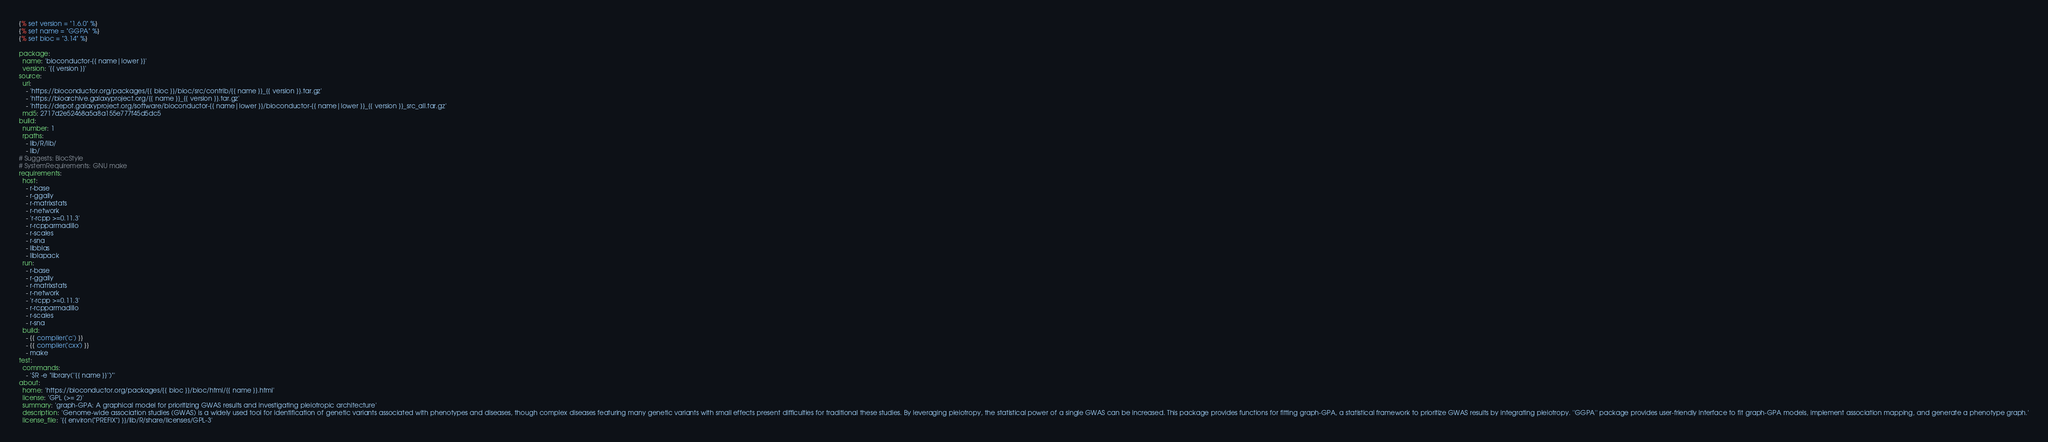<code> <loc_0><loc_0><loc_500><loc_500><_YAML_>{% set version = "1.6.0" %}
{% set name = "GGPA" %}
{% set bioc = "3.14" %}

package:
  name: 'bioconductor-{{ name|lower }}'
  version: '{{ version }}'
source:
  url:
    - 'https://bioconductor.org/packages/{{ bioc }}/bioc/src/contrib/{{ name }}_{{ version }}.tar.gz'
    - 'https://bioarchive.galaxyproject.org/{{ name }}_{{ version }}.tar.gz'
    - 'https://depot.galaxyproject.org/software/bioconductor-{{ name|lower }}/bioconductor-{{ name|lower }}_{{ version }}_src_all.tar.gz'
  md5: 2717d2e52468a5a8a155e777f45d5dc5
build:
  number: 1
  rpaths:
    - lib/R/lib/
    - lib/
# Suggests: BiocStyle
# SystemRequirements: GNU make
requirements:
  host:
    - r-base
    - r-ggally
    - r-matrixstats
    - r-network
    - 'r-rcpp >=0.11.3'
    - r-rcpparmadillo
    - r-scales
    - r-sna
    - libblas
    - liblapack
  run:
    - r-base
    - r-ggally
    - r-matrixstats
    - r-network
    - 'r-rcpp >=0.11.3'
    - r-rcpparmadillo
    - r-scales
    - r-sna
  build:
    - {{ compiler('c') }}
    - {{ compiler('cxx') }}
    - make
test:
  commands:
    - '$R -e "library(''{{ name }}'')"'
about:
  home: 'https://bioconductor.org/packages/{{ bioc }}/bioc/html/{{ name }}.html'
  license: 'GPL (>= 2)'
  summary: 'graph-GPA: A graphical model for prioritizing GWAS results and investigating pleiotropic architecture'
  description: 'Genome-wide association studies (GWAS) is a widely used tool for identification of genetic variants associated with phenotypes and diseases, though complex diseases featuring many genetic variants with small effects present difficulties for traditional these studies. By leveraging pleiotropy, the statistical power of a single GWAS can be increased. This package provides functions for fitting graph-GPA, a statistical framework to prioritize GWAS results by integrating pleiotropy. ''GGPA'' package provides user-friendly interface to fit graph-GPA models, implement association mapping, and generate a phenotype graph.'
  license_file: '{{ environ["PREFIX"] }}/lib/R/share/licenses/GPL-3'

</code> 